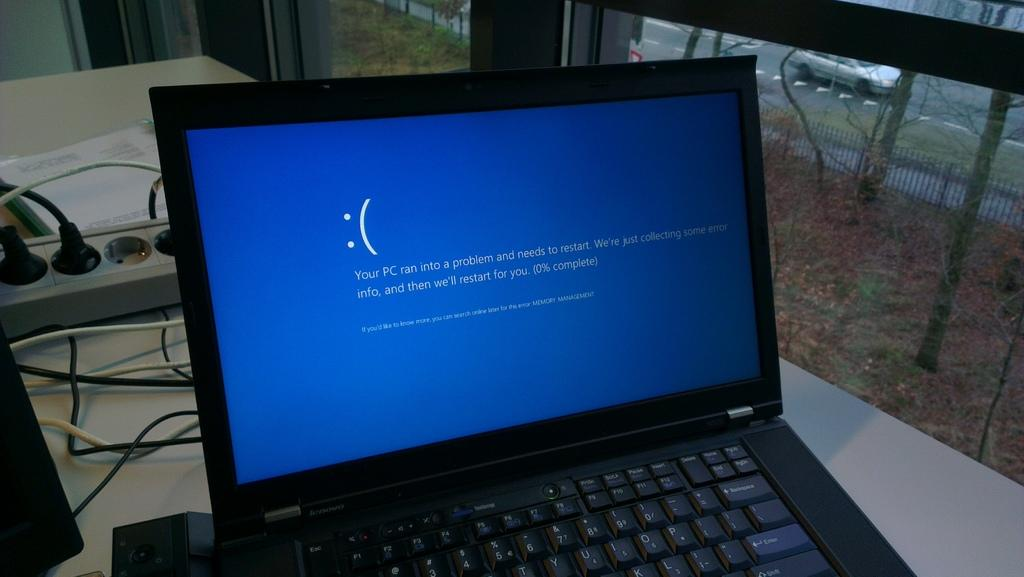<image>
Render a clear and concise summary of the photo. Laptop screen with a blue screen that says "Your PC needs to restart". 